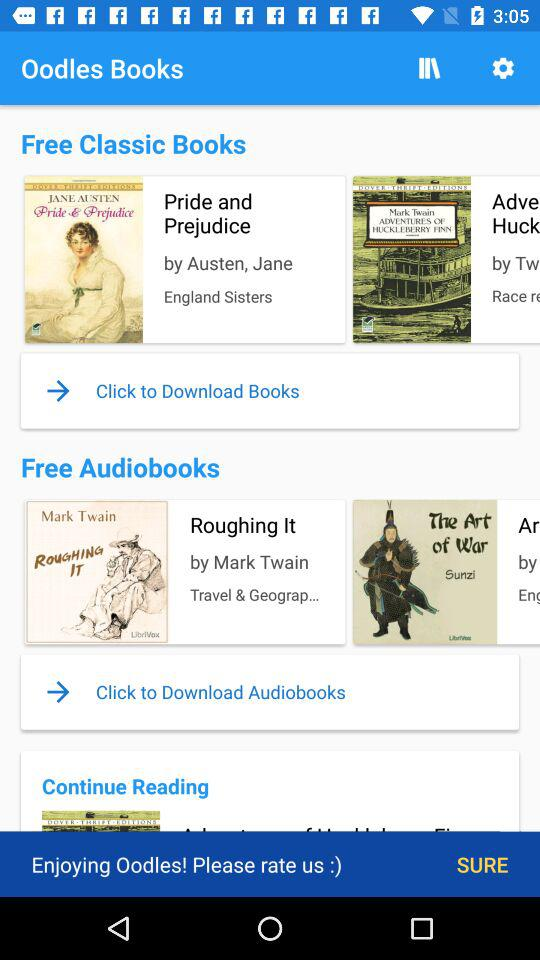How many books are in the Free Classic Books section?
Answer the question using a single word or phrase. 2 